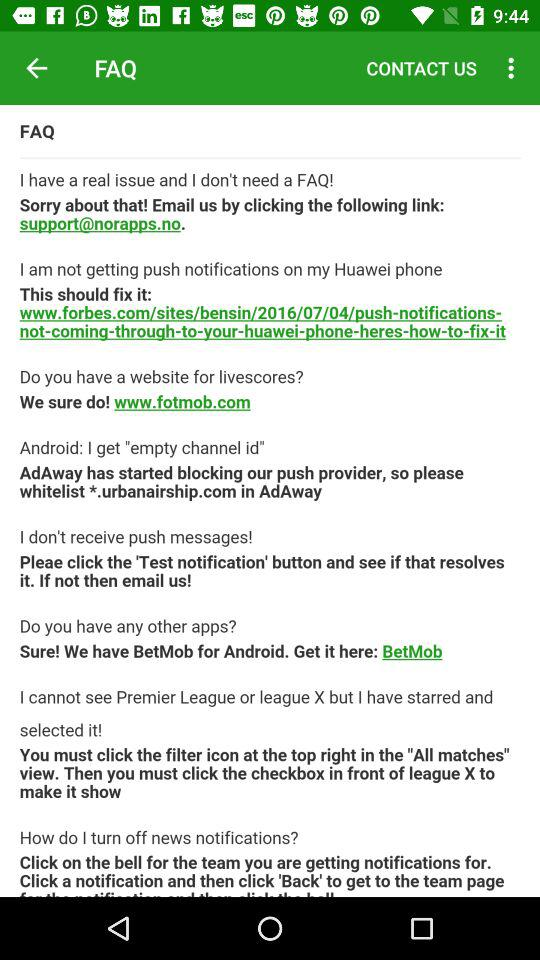What is the support email ID if I have a real issue? The support email ID is support@norapps.no. 